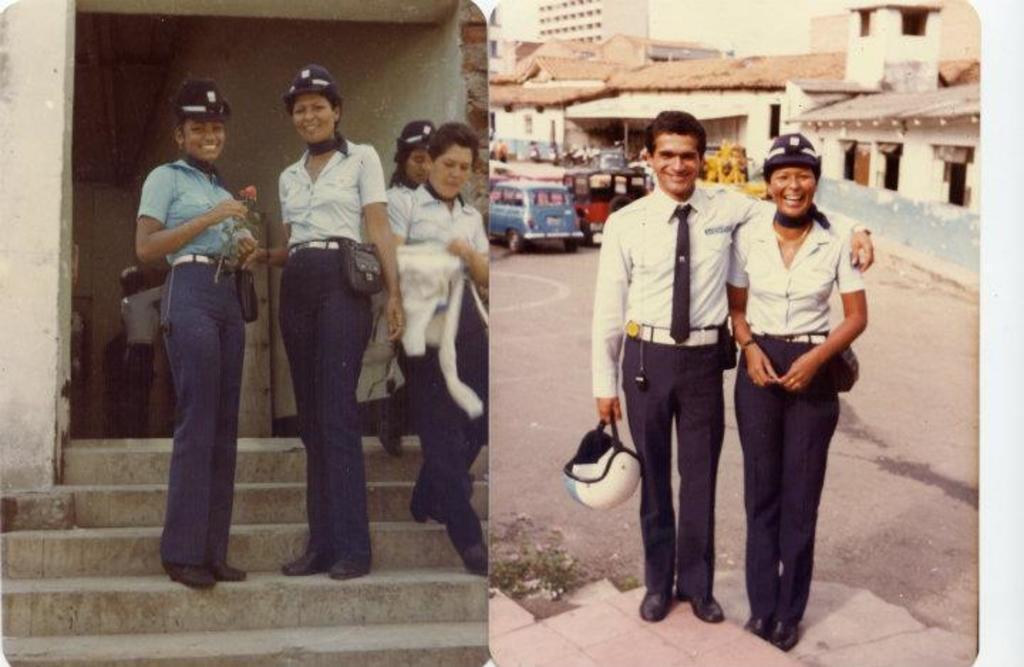Describe this image in one or two sentences. In this picture there are two photos in the image, there are group of girls those who are standing on the left side of the image and there is a boy and a girl on the right side of the image, there are trees and houses in the background area of the image. 